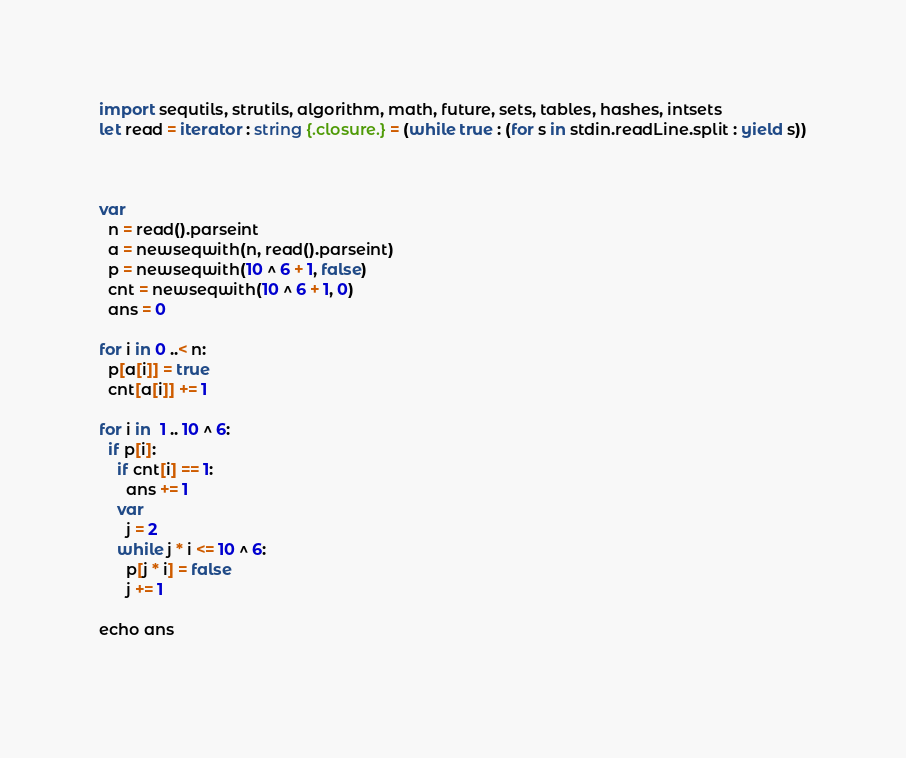Convert code to text. <code><loc_0><loc_0><loc_500><loc_500><_Nim_>import sequtils, strutils, algorithm, math, future, sets, tables, hashes, intsets
let read = iterator : string {.closure.} = (while true : (for s in stdin.readLine.split : yield s))



var
  n = read().parseint
  a = newseqwith(n, read().parseint)
  p = newseqwith(10 ^ 6 + 1, false)
  cnt = newseqwith(10 ^ 6 + 1, 0)
  ans = 0

for i in 0 ..< n:
  p[a[i]] = true
  cnt[a[i]] += 1

for i in  1 .. 10 ^ 6: 
  if p[i]:
    if cnt[i] == 1:
      ans += 1
    var
      j = 2
    while j * i <= 10 ^ 6:
      p[j * i] = false
      j += 1

echo ans
    

</code> 